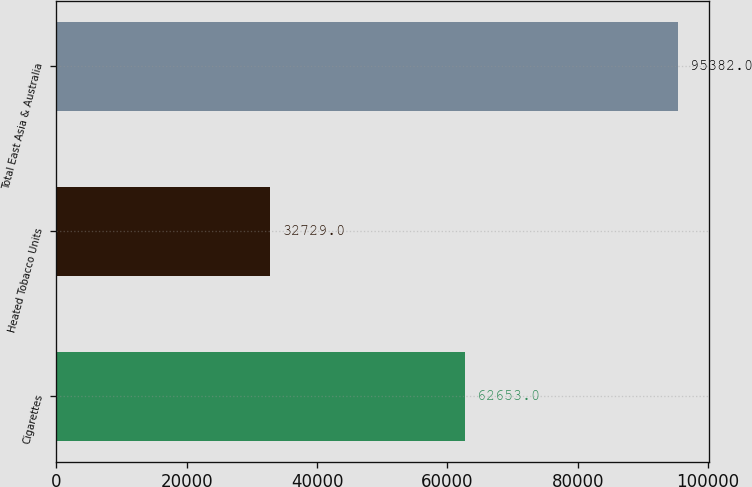<chart> <loc_0><loc_0><loc_500><loc_500><bar_chart><fcel>Cigarettes<fcel>Heated Tobacco Units<fcel>Total East Asia & Australia<nl><fcel>62653<fcel>32729<fcel>95382<nl></chart> 